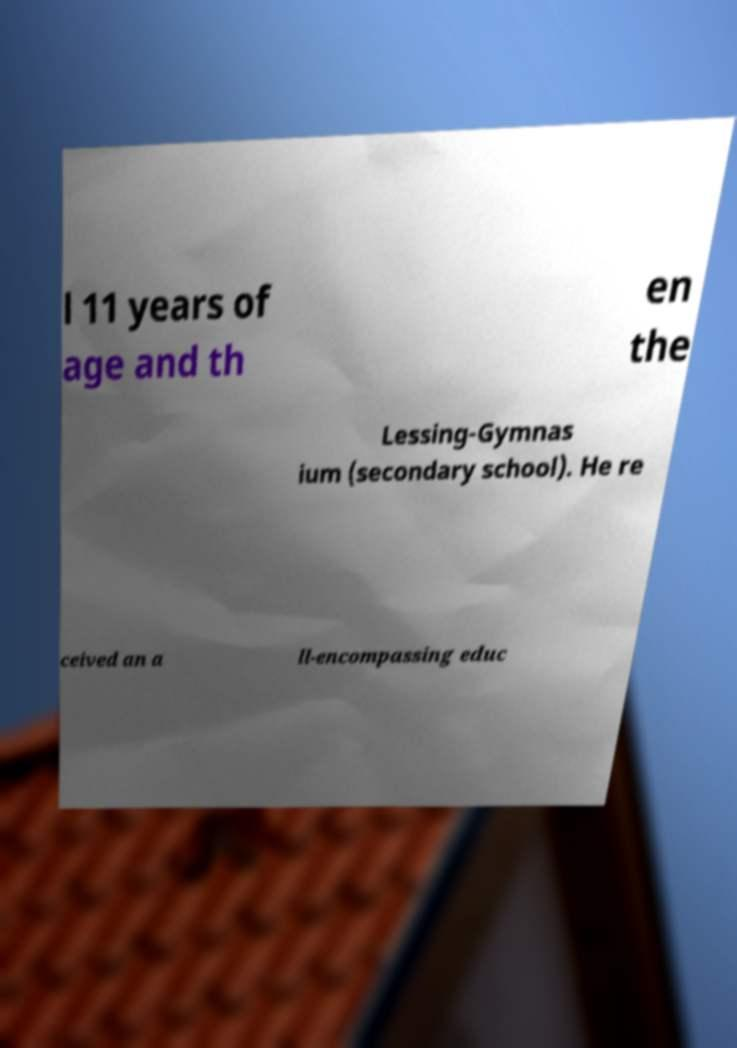There's text embedded in this image that I need extracted. Can you transcribe it verbatim? l 11 years of age and th en the Lessing-Gymnas ium (secondary school). He re ceived an a ll-encompassing educ 